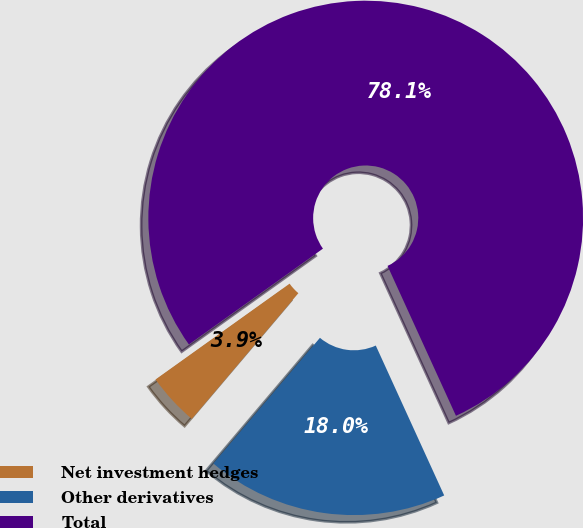Convert chart. <chart><loc_0><loc_0><loc_500><loc_500><pie_chart><fcel>Net investment hedges<fcel>Other derivatives<fcel>Total<nl><fcel>3.93%<fcel>18.01%<fcel>78.07%<nl></chart> 